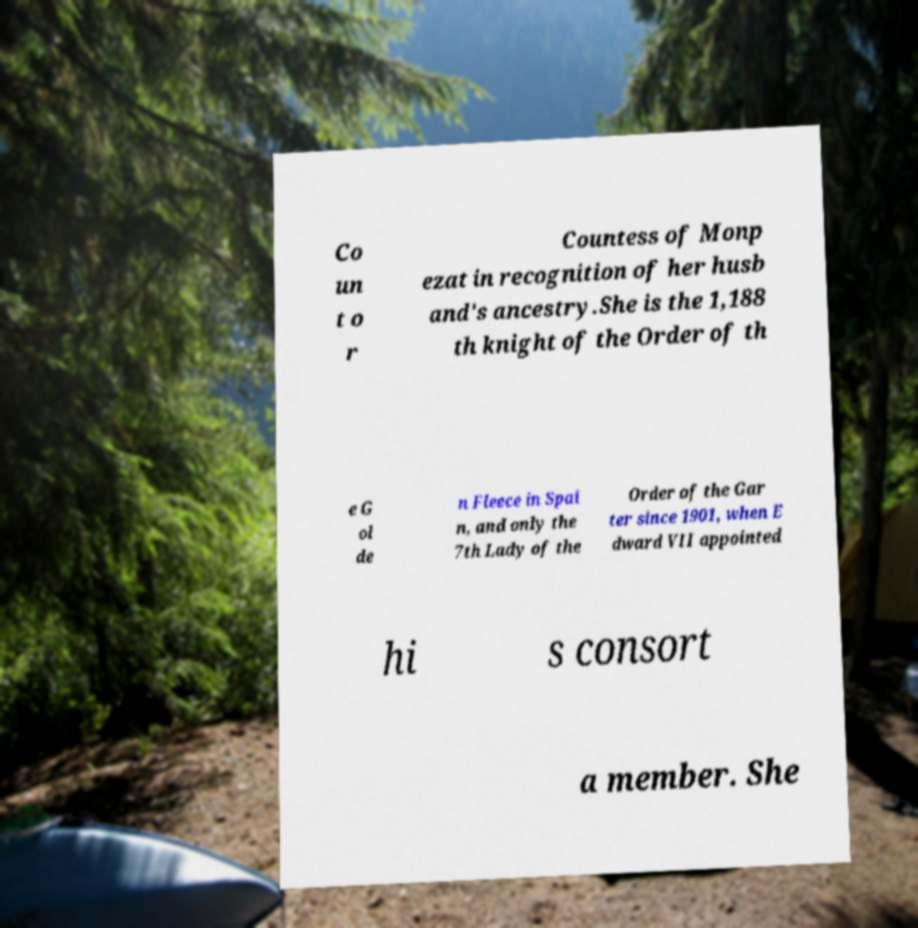Can you accurately transcribe the text from the provided image for me? Co un t o r Countess of Monp ezat in recognition of her husb and's ancestry.She is the 1,188 th knight of the Order of th e G ol de n Fleece in Spai n, and only the 7th Lady of the Order of the Gar ter since 1901, when E dward VII appointed hi s consort a member. She 